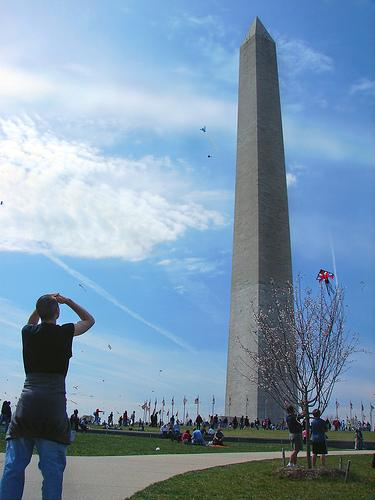What kind of people visit this place throughout the year?

Choices:
A) worshippers
B) politicians
C) tourists
D) athletes tourists 